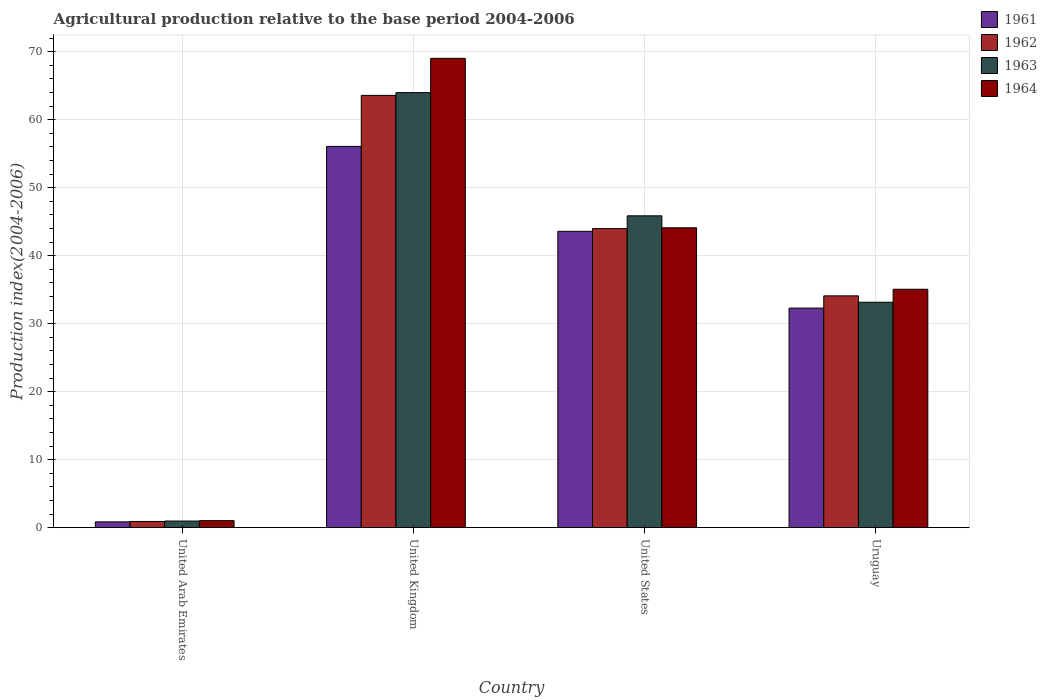How many groups of bars are there?
Provide a short and direct response. 4. Are the number of bars per tick equal to the number of legend labels?
Your response must be concise. Yes. What is the agricultural production index in 1963 in Uruguay?
Provide a short and direct response. 33.15. Across all countries, what is the maximum agricultural production index in 1964?
Your response must be concise. 69.02. In which country was the agricultural production index in 1961 minimum?
Make the answer very short. United Arab Emirates. What is the total agricultural production index in 1963 in the graph?
Offer a terse response. 143.96. What is the difference between the agricultural production index in 1963 in United States and that in Uruguay?
Your response must be concise. 12.71. What is the difference between the agricultural production index in 1961 in United Arab Emirates and the agricultural production index in 1962 in United States?
Offer a terse response. -43.13. What is the average agricultural production index in 1964 per country?
Provide a succinct answer. 37.3. What is the difference between the agricultural production index of/in 1961 and agricultural production index of/in 1963 in United States?
Offer a very short reply. -2.28. In how many countries, is the agricultural production index in 1961 greater than 24?
Your response must be concise. 3. What is the ratio of the agricultural production index in 1962 in United Arab Emirates to that in United States?
Make the answer very short. 0.02. Is the difference between the agricultural production index in 1961 in United Arab Emirates and Uruguay greater than the difference between the agricultural production index in 1963 in United Arab Emirates and Uruguay?
Ensure brevity in your answer.  Yes. What is the difference between the highest and the second highest agricultural production index in 1961?
Provide a succinct answer. 23.78. What is the difference between the highest and the lowest agricultural production index in 1964?
Ensure brevity in your answer.  67.99. In how many countries, is the agricultural production index in 1962 greater than the average agricultural production index in 1962 taken over all countries?
Give a very brief answer. 2. What does the 4th bar from the left in United States represents?
Provide a short and direct response. 1964. Is it the case that in every country, the sum of the agricultural production index in 1962 and agricultural production index in 1963 is greater than the agricultural production index in 1964?
Offer a very short reply. Yes. Are all the bars in the graph horizontal?
Ensure brevity in your answer.  No. How many countries are there in the graph?
Provide a succinct answer. 4. What is the difference between two consecutive major ticks on the Y-axis?
Keep it short and to the point. 10. Are the values on the major ticks of Y-axis written in scientific E-notation?
Keep it short and to the point. No. Does the graph contain any zero values?
Your answer should be compact. No. Where does the legend appear in the graph?
Offer a very short reply. Top right. How are the legend labels stacked?
Keep it short and to the point. Vertical. What is the title of the graph?
Keep it short and to the point. Agricultural production relative to the base period 2004-2006. What is the label or title of the Y-axis?
Keep it short and to the point. Production index(2004-2006). What is the Production index(2004-2006) in 1962 in United Arab Emirates?
Your answer should be compact. 0.91. What is the Production index(2004-2006) of 1964 in United Arab Emirates?
Your answer should be very brief. 1.03. What is the Production index(2004-2006) of 1961 in United Kingdom?
Give a very brief answer. 56.07. What is the Production index(2004-2006) of 1962 in United Kingdom?
Provide a succinct answer. 63.57. What is the Production index(2004-2006) of 1963 in United Kingdom?
Your answer should be very brief. 63.98. What is the Production index(2004-2006) of 1964 in United Kingdom?
Your answer should be very brief. 69.02. What is the Production index(2004-2006) in 1961 in United States?
Your response must be concise. 43.58. What is the Production index(2004-2006) in 1962 in United States?
Provide a short and direct response. 43.98. What is the Production index(2004-2006) of 1963 in United States?
Offer a terse response. 45.86. What is the Production index(2004-2006) of 1964 in United States?
Provide a short and direct response. 44.1. What is the Production index(2004-2006) of 1961 in Uruguay?
Make the answer very short. 32.29. What is the Production index(2004-2006) in 1962 in Uruguay?
Provide a succinct answer. 34.09. What is the Production index(2004-2006) of 1963 in Uruguay?
Offer a very short reply. 33.15. What is the Production index(2004-2006) of 1964 in Uruguay?
Provide a succinct answer. 35.06. Across all countries, what is the maximum Production index(2004-2006) of 1961?
Your answer should be very brief. 56.07. Across all countries, what is the maximum Production index(2004-2006) in 1962?
Offer a terse response. 63.57. Across all countries, what is the maximum Production index(2004-2006) in 1963?
Offer a very short reply. 63.98. Across all countries, what is the maximum Production index(2004-2006) in 1964?
Your answer should be very brief. 69.02. Across all countries, what is the minimum Production index(2004-2006) of 1961?
Keep it short and to the point. 0.85. Across all countries, what is the minimum Production index(2004-2006) of 1962?
Your answer should be compact. 0.91. Across all countries, what is the minimum Production index(2004-2006) of 1964?
Give a very brief answer. 1.03. What is the total Production index(2004-2006) in 1961 in the graph?
Keep it short and to the point. 132.79. What is the total Production index(2004-2006) in 1962 in the graph?
Ensure brevity in your answer.  142.55. What is the total Production index(2004-2006) of 1963 in the graph?
Keep it short and to the point. 143.96. What is the total Production index(2004-2006) of 1964 in the graph?
Offer a terse response. 149.21. What is the difference between the Production index(2004-2006) in 1961 in United Arab Emirates and that in United Kingdom?
Your answer should be very brief. -55.22. What is the difference between the Production index(2004-2006) of 1962 in United Arab Emirates and that in United Kingdom?
Ensure brevity in your answer.  -62.66. What is the difference between the Production index(2004-2006) in 1963 in United Arab Emirates and that in United Kingdom?
Your response must be concise. -63.01. What is the difference between the Production index(2004-2006) of 1964 in United Arab Emirates and that in United Kingdom?
Your response must be concise. -67.99. What is the difference between the Production index(2004-2006) in 1961 in United Arab Emirates and that in United States?
Your answer should be compact. -42.73. What is the difference between the Production index(2004-2006) of 1962 in United Arab Emirates and that in United States?
Offer a terse response. -43.07. What is the difference between the Production index(2004-2006) in 1963 in United Arab Emirates and that in United States?
Your response must be concise. -44.89. What is the difference between the Production index(2004-2006) in 1964 in United Arab Emirates and that in United States?
Give a very brief answer. -43.07. What is the difference between the Production index(2004-2006) in 1961 in United Arab Emirates and that in Uruguay?
Offer a very short reply. -31.44. What is the difference between the Production index(2004-2006) of 1962 in United Arab Emirates and that in Uruguay?
Offer a terse response. -33.18. What is the difference between the Production index(2004-2006) of 1963 in United Arab Emirates and that in Uruguay?
Offer a very short reply. -32.18. What is the difference between the Production index(2004-2006) of 1964 in United Arab Emirates and that in Uruguay?
Ensure brevity in your answer.  -34.03. What is the difference between the Production index(2004-2006) in 1961 in United Kingdom and that in United States?
Make the answer very short. 12.49. What is the difference between the Production index(2004-2006) of 1962 in United Kingdom and that in United States?
Your response must be concise. 19.59. What is the difference between the Production index(2004-2006) in 1963 in United Kingdom and that in United States?
Provide a succinct answer. 18.12. What is the difference between the Production index(2004-2006) in 1964 in United Kingdom and that in United States?
Give a very brief answer. 24.92. What is the difference between the Production index(2004-2006) of 1961 in United Kingdom and that in Uruguay?
Provide a short and direct response. 23.78. What is the difference between the Production index(2004-2006) in 1962 in United Kingdom and that in Uruguay?
Your answer should be very brief. 29.48. What is the difference between the Production index(2004-2006) of 1963 in United Kingdom and that in Uruguay?
Your answer should be compact. 30.83. What is the difference between the Production index(2004-2006) in 1964 in United Kingdom and that in Uruguay?
Keep it short and to the point. 33.96. What is the difference between the Production index(2004-2006) in 1961 in United States and that in Uruguay?
Offer a very short reply. 11.29. What is the difference between the Production index(2004-2006) in 1962 in United States and that in Uruguay?
Your response must be concise. 9.89. What is the difference between the Production index(2004-2006) of 1963 in United States and that in Uruguay?
Your response must be concise. 12.71. What is the difference between the Production index(2004-2006) of 1964 in United States and that in Uruguay?
Your answer should be compact. 9.04. What is the difference between the Production index(2004-2006) in 1961 in United Arab Emirates and the Production index(2004-2006) in 1962 in United Kingdom?
Give a very brief answer. -62.72. What is the difference between the Production index(2004-2006) of 1961 in United Arab Emirates and the Production index(2004-2006) of 1963 in United Kingdom?
Offer a terse response. -63.13. What is the difference between the Production index(2004-2006) in 1961 in United Arab Emirates and the Production index(2004-2006) in 1964 in United Kingdom?
Provide a succinct answer. -68.17. What is the difference between the Production index(2004-2006) of 1962 in United Arab Emirates and the Production index(2004-2006) of 1963 in United Kingdom?
Keep it short and to the point. -63.07. What is the difference between the Production index(2004-2006) in 1962 in United Arab Emirates and the Production index(2004-2006) in 1964 in United Kingdom?
Your response must be concise. -68.11. What is the difference between the Production index(2004-2006) in 1963 in United Arab Emirates and the Production index(2004-2006) in 1964 in United Kingdom?
Provide a short and direct response. -68.05. What is the difference between the Production index(2004-2006) of 1961 in United Arab Emirates and the Production index(2004-2006) of 1962 in United States?
Make the answer very short. -43.13. What is the difference between the Production index(2004-2006) in 1961 in United Arab Emirates and the Production index(2004-2006) in 1963 in United States?
Your response must be concise. -45.01. What is the difference between the Production index(2004-2006) of 1961 in United Arab Emirates and the Production index(2004-2006) of 1964 in United States?
Provide a succinct answer. -43.25. What is the difference between the Production index(2004-2006) in 1962 in United Arab Emirates and the Production index(2004-2006) in 1963 in United States?
Give a very brief answer. -44.95. What is the difference between the Production index(2004-2006) of 1962 in United Arab Emirates and the Production index(2004-2006) of 1964 in United States?
Your answer should be very brief. -43.19. What is the difference between the Production index(2004-2006) in 1963 in United Arab Emirates and the Production index(2004-2006) in 1964 in United States?
Give a very brief answer. -43.13. What is the difference between the Production index(2004-2006) of 1961 in United Arab Emirates and the Production index(2004-2006) of 1962 in Uruguay?
Provide a succinct answer. -33.24. What is the difference between the Production index(2004-2006) in 1961 in United Arab Emirates and the Production index(2004-2006) in 1963 in Uruguay?
Offer a terse response. -32.3. What is the difference between the Production index(2004-2006) of 1961 in United Arab Emirates and the Production index(2004-2006) of 1964 in Uruguay?
Offer a terse response. -34.21. What is the difference between the Production index(2004-2006) in 1962 in United Arab Emirates and the Production index(2004-2006) in 1963 in Uruguay?
Your response must be concise. -32.24. What is the difference between the Production index(2004-2006) in 1962 in United Arab Emirates and the Production index(2004-2006) in 1964 in Uruguay?
Your response must be concise. -34.15. What is the difference between the Production index(2004-2006) in 1963 in United Arab Emirates and the Production index(2004-2006) in 1964 in Uruguay?
Make the answer very short. -34.09. What is the difference between the Production index(2004-2006) in 1961 in United Kingdom and the Production index(2004-2006) in 1962 in United States?
Give a very brief answer. 12.09. What is the difference between the Production index(2004-2006) in 1961 in United Kingdom and the Production index(2004-2006) in 1963 in United States?
Provide a succinct answer. 10.21. What is the difference between the Production index(2004-2006) in 1961 in United Kingdom and the Production index(2004-2006) in 1964 in United States?
Provide a succinct answer. 11.97. What is the difference between the Production index(2004-2006) of 1962 in United Kingdom and the Production index(2004-2006) of 1963 in United States?
Provide a succinct answer. 17.71. What is the difference between the Production index(2004-2006) in 1962 in United Kingdom and the Production index(2004-2006) in 1964 in United States?
Offer a terse response. 19.47. What is the difference between the Production index(2004-2006) in 1963 in United Kingdom and the Production index(2004-2006) in 1964 in United States?
Your response must be concise. 19.88. What is the difference between the Production index(2004-2006) of 1961 in United Kingdom and the Production index(2004-2006) of 1962 in Uruguay?
Give a very brief answer. 21.98. What is the difference between the Production index(2004-2006) in 1961 in United Kingdom and the Production index(2004-2006) in 1963 in Uruguay?
Your response must be concise. 22.92. What is the difference between the Production index(2004-2006) in 1961 in United Kingdom and the Production index(2004-2006) in 1964 in Uruguay?
Your response must be concise. 21.01. What is the difference between the Production index(2004-2006) of 1962 in United Kingdom and the Production index(2004-2006) of 1963 in Uruguay?
Your answer should be compact. 30.42. What is the difference between the Production index(2004-2006) in 1962 in United Kingdom and the Production index(2004-2006) in 1964 in Uruguay?
Provide a succinct answer. 28.51. What is the difference between the Production index(2004-2006) of 1963 in United Kingdom and the Production index(2004-2006) of 1964 in Uruguay?
Make the answer very short. 28.92. What is the difference between the Production index(2004-2006) in 1961 in United States and the Production index(2004-2006) in 1962 in Uruguay?
Provide a succinct answer. 9.49. What is the difference between the Production index(2004-2006) in 1961 in United States and the Production index(2004-2006) in 1963 in Uruguay?
Give a very brief answer. 10.43. What is the difference between the Production index(2004-2006) in 1961 in United States and the Production index(2004-2006) in 1964 in Uruguay?
Ensure brevity in your answer.  8.52. What is the difference between the Production index(2004-2006) in 1962 in United States and the Production index(2004-2006) in 1963 in Uruguay?
Ensure brevity in your answer.  10.83. What is the difference between the Production index(2004-2006) in 1962 in United States and the Production index(2004-2006) in 1964 in Uruguay?
Offer a terse response. 8.92. What is the average Production index(2004-2006) of 1961 per country?
Give a very brief answer. 33.2. What is the average Production index(2004-2006) in 1962 per country?
Ensure brevity in your answer.  35.64. What is the average Production index(2004-2006) of 1963 per country?
Provide a succinct answer. 35.99. What is the average Production index(2004-2006) in 1964 per country?
Provide a short and direct response. 37.3. What is the difference between the Production index(2004-2006) of 1961 and Production index(2004-2006) of 1962 in United Arab Emirates?
Keep it short and to the point. -0.06. What is the difference between the Production index(2004-2006) in 1961 and Production index(2004-2006) in 1963 in United Arab Emirates?
Your answer should be very brief. -0.12. What is the difference between the Production index(2004-2006) in 1961 and Production index(2004-2006) in 1964 in United Arab Emirates?
Ensure brevity in your answer.  -0.18. What is the difference between the Production index(2004-2006) in 1962 and Production index(2004-2006) in 1963 in United Arab Emirates?
Your answer should be very brief. -0.06. What is the difference between the Production index(2004-2006) in 1962 and Production index(2004-2006) in 1964 in United Arab Emirates?
Make the answer very short. -0.12. What is the difference between the Production index(2004-2006) of 1963 and Production index(2004-2006) of 1964 in United Arab Emirates?
Keep it short and to the point. -0.06. What is the difference between the Production index(2004-2006) of 1961 and Production index(2004-2006) of 1963 in United Kingdom?
Offer a very short reply. -7.91. What is the difference between the Production index(2004-2006) of 1961 and Production index(2004-2006) of 1964 in United Kingdom?
Your response must be concise. -12.95. What is the difference between the Production index(2004-2006) in 1962 and Production index(2004-2006) in 1963 in United Kingdom?
Provide a short and direct response. -0.41. What is the difference between the Production index(2004-2006) in 1962 and Production index(2004-2006) in 1964 in United Kingdom?
Ensure brevity in your answer.  -5.45. What is the difference between the Production index(2004-2006) of 1963 and Production index(2004-2006) of 1964 in United Kingdom?
Make the answer very short. -5.04. What is the difference between the Production index(2004-2006) in 1961 and Production index(2004-2006) in 1962 in United States?
Your answer should be very brief. -0.4. What is the difference between the Production index(2004-2006) in 1961 and Production index(2004-2006) in 1963 in United States?
Your answer should be compact. -2.28. What is the difference between the Production index(2004-2006) in 1961 and Production index(2004-2006) in 1964 in United States?
Ensure brevity in your answer.  -0.52. What is the difference between the Production index(2004-2006) in 1962 and Production index(2004-2006) in 1963 in United States?
Your answer should be compact. -1.88. What is the difference between the Production index(2004-2006) of 1962 and Production index(2004-2006) of 1964 in United States?
Ensure brevity in your answer.  -0.12. What is the difference between the Production index(2004-2006) in 1963 and Production index(2004-2006) in 1964 in United States?
Your response must be concise. 1.76. What is the difference between the Production index(2004-2006) of 1961 and Production index(2004-2006) of 1963 in Uruguay?
Offer a very short reply. -0.86. What is the difference between the Production index(2004-2006) in 1961 and Production index(2004-2006) in 1964 in Uruguay?
Your answer should be compact. -2.77. What is the difference between the Production index(2004-2006) of 1962 and Production index(2004-2006) of 1963 in Uruguay?
Offer a very short reply. 0.94. What is the difference between the Production index(2004-2006) in 1962 and Production index(2004-2006) in 1964 in Uruguay?
Provide a short and direct response. -0.97. What is the difference between the Production index(2004-2006) in 1963 and Production index(2004-2006) in 1964 in Uruguay?
Give a very brief answer. -1.91. What is the ratio of the Production index(2004-2006) in 1961 in United Arab Emirates to that in United Kingdom?
Ensure brevity in your answer.  0.02. What is the ratio of the Production index(2004-2006) of 1962 in United Arab Emirates to that in United Kingdom?
Provide a succinct answer. 0.01. What is the ratio of the Production index(2004-2006) in 1963 in United Arab Emirates to that in United Kingdom?
Offer a very short reply. 0.02. What is the ratio of the Production index(2004-2006) of 1964 in United Arab Emirates to that in United Kingdom?
Keep it short and to the point. 0.01. What is the ratio of the Production index(2004-2006) in 1961 in United Arab Emirates to that in United States?
Provide a succinct answer. 0.02. What is the ratio of the Production index(2004-2006) of 1962 in United Arab Emirates to that in United States?
Your answer should be very brief. 0.02. What is the ratio of the Production index(2004-2006) in 1963 in United Arab Emirates to that in United States?
Provide a short and direct response. 0.02. What is the ratio of the Production index(2004-2006) of 1964 in United Arab Emirates to that in United States?
Offer a terse response. 0.02. What is the ratio of the Production index(2004-2006) in 1961 in United Arab Emirates to that in Uruguay?
Your response must be concise. 0.03. What is the ratio of the Production index(2004-2006) in 1962 in United Arab Emirates to that in Uruguay?
Your answer should be compact. 0.03. What is the ratio of the Production index(2004-2006) of 1963 in United Arab Emirates to that in Uruguay?
Keep it short and to the point. 0.03. What is the ratio of the Production index(2004-2006) of 1964 in United Arab Emirates to that in Uruguay?
Provide a short and direct response. 0.03. What is the ratio of the Production index(2004-2006) of 1961 in United Kingdom to that in United States?
Ensure brevity in your answer.  1.29. What is the ratio of the Production index(2004-2006) of 1962 in United Kingdom to that in United States?
Make the answer very short. 1.45. What is the ratio of the Production index(2004-2006) in 1963 in United Kingdom to that in United States?
Ensure brevity in your answer.  1.4. What is the ratio of the Production index(2004-2006) of 1964 in United Kingdom to that in United States?
Offer a very short reply. 1.57. What is the ratio of the Production index(2004-2006) in 1961 in United Kingdom to that in Uruguay?
Provide a succinct answer. 1.74. What is the ratio of the Production index(2004-2006) of 1962 in United Kingdom to that in Uruguay?
Provide a short and direct response. 1.86. What is the ratio of the Production index(2004-2006) of 1963 in United Kingdom to that in Uruguay?
Provide a succinct answer. 1.93. What is the ratio of the Production index(2004-2006) of 1964 in United Kingdom to that in Uruguay?
Provide a succinct answer. 1.97. What is the ratio of the Production index(2004-2006) in 1961 in United States to that in Uruguay?
Make the answer very short. 1.35. What is the ratio of the Production index(2004-2006) in 1962 in United States to that in Uruguay?
Offer a very short reply. 1.29. What is the ratio of the Production index(2004-2006) in 1963 in United States to that in Uruguay?
Provide a short and direct response. 1.38. What is the ratio of the Production index(2004-2006) in 1964 in United States to that in Uruguay?
Provide a short and direct response. 1.26. What is the difference between the highest and the second highest Production index(2004-2006) of 1961?
Your answer should be compact. 12.49. What is the difference between the highest and the second highest Production index(2004-2006) in 1962?
Give a very brief answer. 19.59. What is the difference between the highest and the second highest Production index(2004-2006) in 1963?
Give a very brief answer. 18.12. What is the difference between the highest and the second highest Production index(2004-2006) of 1964?
Provide a short and direct response. 24.92. What is the difference between the highest and the lowest Production index(2004-2006) of 1961?
Your answer should be compact. 55.22. What is the difference between the highest and the lowest Production index(2004-2006) of 1962?
Offer a very short reply. 62.66. What is the difference between the highest and the lowest Production index(2004-2006) of 1963?
Your answer should be very brief. 63.01. What is the difference between the highest and the lowest Production index(2004-2006) in 1964?
Your answer should be compact. 67.99. 